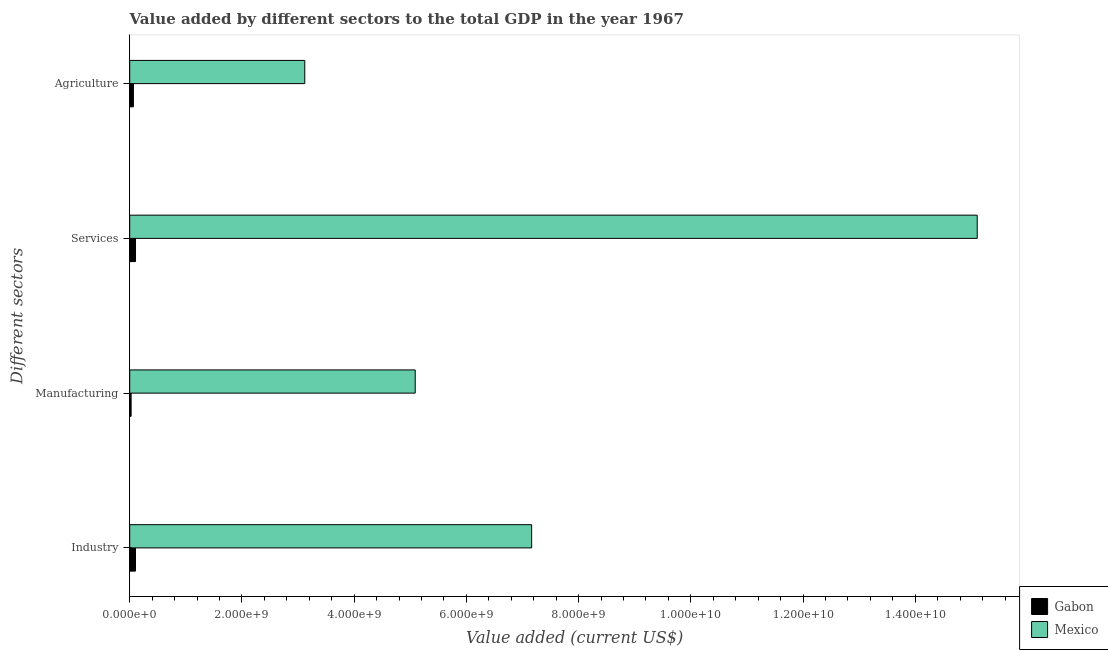How many different coloured bars are there?
Offer a very short reply. 2. Are the number of bars per tick equal to the number of legend labels?
Offer a very short reply. Yes. How many bars are there on the 1st tick from the bottom?
Provide a succinct answer. 2. What is the label of the 1st group of bars from the top?
Provide a short and direct response. Agriculture. What is the value added by services sector in Mexico?
Ensure brevity in your answer.  1.51e+1. Across all countries, what is the maximum value added by agricultural sector?
Make the answer very short. 3.12e+09. Across all countries, what is the minimum value added by manufacturing sector?
Provide a short and direct response. 2.48e+07. In which country was the value added by industrial sector minimum?
Provide a succinct answer. Gabon. What is the total value added by services sector in the graph?
Give a very brief answer. 1.52e+1. What is the difference between the value added by manufacturing sector in Gabon and that in Mexico?
Your answer should be very brief. -5.06e+09. What is the difference between the value added by manufacturing sector in Mexico and the value added by services sector in Gabon?
Keep it short and to the point. 4.99e+09. What is the average value added by agricultural sector per country?
Offer a very short reply. 1.59e+09. What is the difference between the value added by industrial sector and value added by manufacturing sector in Mexico?
Your response must be concise. 2.08e+09. In how many countries, is the value added by manufacturing sector greater than 11200000000 US$?
Keep it short and to the point. 0. What is the ratio of the value added by services sector in Gabon to that in Mexico?
Offer a very short reply. 0.01. Is the difference between the value added by services sector in Mexico and Gabon greater than the difference between the value added by manufacturing sector in Mexico and Gabon?
Make the answer very short. Yes. What is the difference between the highest and the second highest value added by industrial sector?
Provide a succinct answer. 7.06e+09. What is the difference between the highest and the lowest value added by agricultural sector?
Make the answer very short. 3.05e+09. Is it the case that in every country, the sum of the value added by manufacturing sector and value added by agricultural sector is greater than the sum of value added by industrial sector and value added by services sector?
Keep it short and to the point. No. What does the 1st bar from the top in Industry represents?
Your answer should be compact. Mexico. Are all the bars in the graph horizontal?
Offer a very short reply. Yes. How many countries are there in the graph?
Ensure brevity in your answer.  2. What is the difference between two consecutive major ticks on the X-axis?
Keep it short and to the point. 2.00e+09. Are the values on the major ticks of X-axis written in scientific E-notation?
Make the answer very short. Yes. Does the graph contain any zero values?
Your answer should be compact. No. How are the legend labels stacked?
Your response must be concise. Vertical. What is the title of the graph?
Give a very brief answer. Value added by different sectors to the total GDP in the year 1967. What is the label or title of the X-axis?
Make the answer very short. Value added (current US$). What is the label or title of the Y-axis?
Your response must be concise. Different sectors. What is the Value added (current US$) in Gabon in Industry?
Offer a terse response. 1.03e+08. What is the Value added (current US$) in Mexico in Industry?
Provide a succinct answer. 7.16e+09. What is the Value added (current US$) in Gabon in Manufacturing?
Your response must be concise. 2.48e+07. What is the Value added (current US$) in Mexico in Manufacturing?
Provide a succinct answer. 5.09e+09. What is the Value added (current US$) in Gabon in Services?
Ensure brevity in your answer.  1.03e+08. What is the Value added (current US$) of Mexico in Services?
Make the answer very short. 1.51e+1. What is the Value added (current US$) in Gabon in Agriculture?
Your answer should be very brief. 6.54e+07. What is the Value added (current US$) in Mexico in Agriculture?
Offer a very short reply. 3.12e+09. Across all Different sectors, what is the maximum Value added (current US$) in Gabon?
Your answer should be very brief. 1.03e+08. Across all Different sectors, what is the maximum Value added (current US$) in Mexico?
Keep it short and to the point. 1.51e+1. Across all Different sectors, what is the minimum Value added (current US$) in Gabon?
Offer a very short reply. 2.48e+07. Across all Different sectors, what is the minimum Value added (current US$) of Mexico?
Your response must be concise. 3.12e+09. What is the total Value added (current US$) of Gabon in the graph?
Provide a short and direct response. 2.96e+08. What is the total Value added (current US$) in Mexico in the graph?
Ensure brevity in your answer.  3.05e+1. What is the difference between the Value added (current US$) of Gabon in Industry and that in Manufacturing?
Make the answer very short. 7.80e+07. What is the difference between the Value added (current US$) of Mexico in Industry and that in Manufacturing?
Keep it short and to the point. 2.08e+09. What is the difference between the Value added (current US$) of Gabon in Industry and that in Services?
Offer a terse response. -4.06e+05. What is the difference between the Value added (current US$) in Mexico in Industry and that in Services?
Offer a terse response. -7.94e+09. What is the difference between the Value added (current US$) of Gabon in Industry and that in Agriculture?
Ensure brevity in your answer.  3.74e+07. What is the difference between the Value added (current US$) in Mexico in Industry and that in Agriculture?
Your answer should be very brief. 4.04e+09. What is the difference between the Value added (current US$) of Gabon in Manufacturing and that in Services?
Your answer should be very brief. -7.85e+07. What is the difference between the Value added (current US$) of Mexico in Manufacturing and that in Services?
Ensure brevity in your answer.  -1.00e+1. What is the difference between the Value added (current US$) of Gabon in Manufacturing and that in Agriculture?
Give a very brief answer. -4.07e+07. What is the difference between the Value added (current US$) of Mexico in Manufacturing and that in Agriculture?
Give a very brief answer. 1.97e+09. What is the difference between the Value added (current US$) of Gabon in Services and that in Agriculture?
Give a very brief answer. 3.78e+07. What is the difference between the Value added (current US$) in Mexico in Services and that in Agriculture?
Your answer should be very brief. 1.20e+1. What is the difference between the Value added (current US$) in Gabon in Industry and the Value added (current US$) in Mexico in Manufacturing?
Give a very brief answer. -4.99e+09. What is the difference between the Value added (current US$) of Gabon in Industry and the Value added (current US$) of Mexico in Services?
Give a very brief answer. -1.50e+1. What is the difference between the Value added (current US$) of Gabon in Industry and the Value added (current US$) of Mexico in Agriculture?
Keep it short and to the point. -3.02e+09. What is the difference between the Value added (current US$) in Gabon in Manufacturing and the Value added (current US$) in Mexico in Services?
Provide a succinct answer. -1.51e+1. What is the difference between the Value added (current US$) in Gabon in Manufacturing and the Value added (current US$) in Mexico in Agriculture?
Make the answer very short. -3.10e+09. What is the difference between the Value added (current US$) of Gabon in Services and the Value added (current US$) of Mexico in Agriculture?
Give a very brief answer. -3.02e+09. What is the average Value added (current US$) of Gabon per Different sectors?
Your response must be concise. 7.41e+07. What is the average Value added (current US$) in Mexico per Different sectors?
Give a very brief answer. 7.62e+09. What is the difference between the Value added (current US$) in Gabon and Value added (current US$) in Mexico in Industry?
Make the answer very short. -7.06e+09. What is the difference between the Value added (current US$) of Gabon and Value added (current US$) of Mexico in Manufacturing?
Give a very brief answer. -5.06e+09. What is the difference between the Value added (current US$) in Gabon and Value added (current US$) in Mexico in Services?
Your response must be concise. -1.50e+1. What is the difference between the Value added (current US$) of Gabon and Value added (current US$) of Mexico in Agriculture?
Offer a very short reply. -3.05e+09. What is the ratio of the Value added (current US$) of Gabon in Industry to that in Manufacturing?
Give a very brief answer. 4.15. What is the ratio of the Value added (current US$) in Mexico in Industry to that in Manufacturing?
Provide a succinct answer. 1.41. What is the ratio of the Value added (current US$) in Mexico in Industry to that in Services?
Make the answer very short. 0.47. What is the ratio of the Value added (current US$) of Gabon in Industry to that in Agriculture?
Ensure brevity in your answer.  1.57. What is the ratio of the Value added (current US$) of Mexico in Industry to that in Agriculture?
Provide a short and direct response. 2.3. What is the ratio of the Value added (current US$) of Gabon in Manufacturing to that in Services?
Offer a very short reply. 0.24. What is the ratio of the Value added (current US$) in Mexico in Manufacturing to that in Services?
Your answer should be very brief. 0.34. What is the ratio of the Value added (current US$) of Gabon in Manufacturing to that in Agriculture?
Ensure brevity in your answer.  0.38. What is the ratio of the Value added (current US$) in Mexico in Manufacturing to that in Agriculture?
Provide a short and direct response. 1.63. What is the ratio of the Value added (current US$) of Gabon in Services to that in Agriculture?
Ensure brevity in your answer.  1.58. What is the ratio of the Value added (current US$) in Mexico in Services to that in Agriculture?
Keep it short and to the point. 4.84. What is the difference between the highest and the second highest Value added (current US$) in Gabon?
Make the answer very short. 4.06e+05. What is the difference between the highest and the second highest Value added (current US$) of Mexico?
Your answer should be compact. 7.94e+09. What is the difference between the highest and the lowest Value added (current US$) of Gabon?
Offer a terse response. 7.85e+07. What is the difference between the highest and the lowest Value added (current US$) in Mexico?
Make the answer very short. 1.20e+1. 